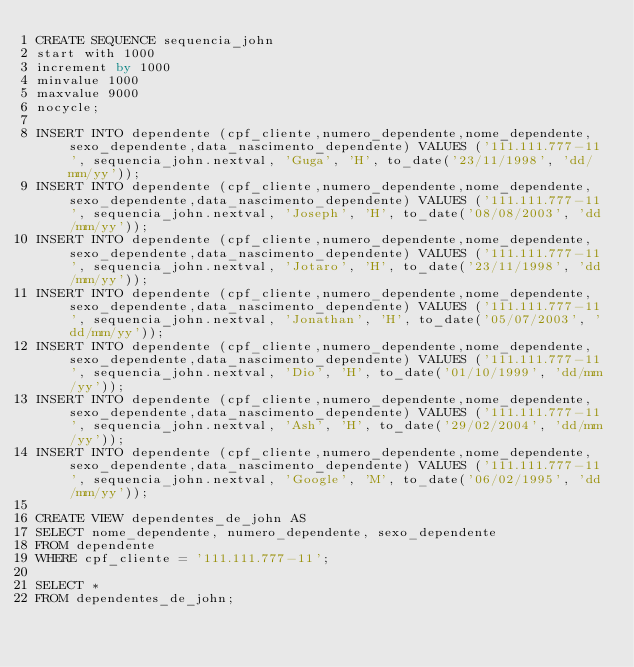Convert code to text. <code><loc_0><loc_0><loc_500><loc_500><_SQL_>CREATE SEQUENCE sequencia_john
start with 1000
increment by 1000
minvalue 1000
maxvalue 9000
nocycle;

INSERT INTO dependente (cpf_cliente,numero_dependente,nome_dependente,sexo_dependente,data_nascimento_dependente) VALUES ('111.111.777-11', sequencia_john.nextval, 'Guga', 'H', to_date('23/11/1998', 'dd/mm/yy'));
INSERT INTO dependente (cpf_cliente,numero_dependente,nome_dependente,sexo_dependente,data_nascimento_dependente) VALUES ('111.111.777-11', sequencia_john.nextval, 'Joseph', 'H', to_date('08/08/2003', 'dd/mm/yy'));
INSERT INTO dependente (cpf_cliente,numero_dependente,nome_dependente,sexo_dependente,data_nascimento_dependente) VALUES ('111.111.777-11', sequencia_john.nextval, 'Jotaro', 'H', to_date('23/11/1998', 'dd/mm/yy'));
INSERT INTO dependente (cpf_cliente,numero_dependente,nome_dependente,sexo_dependente,data_nascimento_dependente) VALUES ('111.111.777-11', sequencia_john.nextval, 'Jonathan', 'H', to_date('05/07/2003', 'dd/mm/yy'));
INSERT INTO dependente (cpf_cliente,numero_dependente,nome_dependente,sexo_dependente,data_nascimento_dependente) VALUES ('111.111.777-11', sequencia_john.nextval, 'Dio', 'H', to_date('01/10/1999', 'dd/mm/yy'));
INSERT INTO dependente (cpf_cliente,numero_dependente,nome_dependente,sexo_dependente,data_nascimento_dependente) VALUES ('111.111.777-11', sequencia_john.nextval, 'Ash', 'H', to_date('29/02/2004', 'dd/mm/yy'));
INSERT INTO dependente (cpf_cliente,numero_dependente,nome_dependente,sexo_dependente,data_nascimento_dependente) VALUES ('111.111.777-11', sequencia_john.nextval, 'Google', 'M', to_date('06/02/1995', 'dd/mm/yy'));

CREATE VIEW dependentes_de_john AS
SELECT nome_dependente, numero_dependente, sexo_dependente
FROM dependente
WHERE cpf_cliente = '111.111.777-11';

SELECT * 
FROM dependentes_de_john;
</code> 